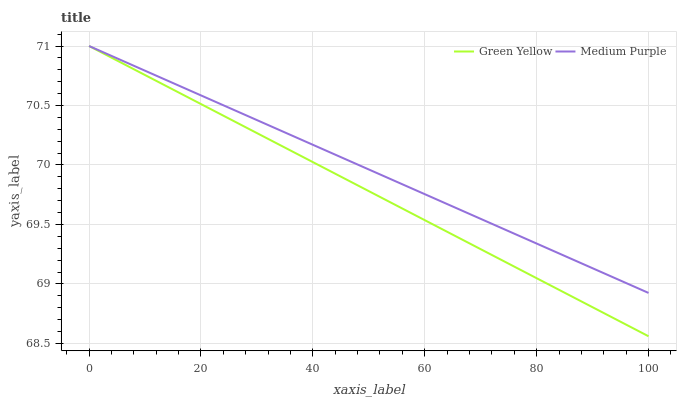Does Green Yellow have the minimum area under the curve?
Answer yes or no. Yes. Does Medium Purple have the maximum area under the curve?
Answer yes or no. Yes. Does Green Yellow have the maximum area under the curve?
Answer yes or no. No. Is Medium Purple the smoothest?
Answer yes or no. Yes. Is Green Yellow the roughest?
Answer yes or no. Yes. Is Green Yellow the smoothest?
Answer yes or no. No. Does Green Yellow have the lowest value?
Answer yes or no. Yes. Does Green Yellow have the highest value?
Answer yes or no. Yes. Does Green Yellow intersect Medium Purple?
Answer yes or no. Yes. Is Green Yellow less than Medium Purple?
Answer yes or no. No. Is Green Yellow greater than Medium Purple?
Answer yes or no. No. 